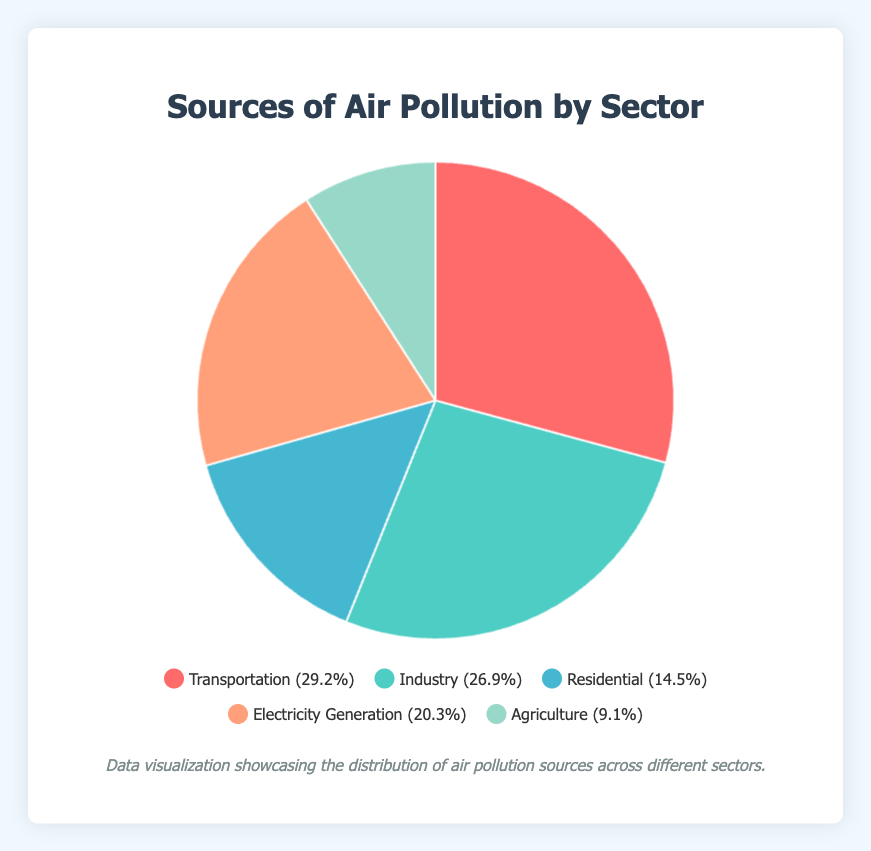How much more does the Transportation sector contribute to air pollution compared to the Residential sector? To find this, subtract the percentage of the Residential sector from the percentage of the Transportation sector: 29.2% - 14.5% = 14.7%
Answer: 14.7% What is the combined percentage of air pollution from the Industry and Electricity Generation sectors? Add together the percentages of the Industry and Electricity Generation sectors: 26.9% + 20.3% = 47.2%
Answer: 47.2% Out of the subcategories within the Transportation sector, which contributes the most to air pollution? The subcategory with the highest percentage under the Transportation sector is Passenger Vehicles at 15.0%
Answer: Passenger Vehicles How does the air pollution contribution from Manufacturing compare to the total contribution of the Residential sector? Compare the percentages: Manufacturing contributes 12.5% while the Residential sector contributes 14.5%. Manufacturing is 2.0% less.
Answer: 2.0% less Which sector has the smallest percentage of air pollution contribution, and what is that value? The Agriculture sector has the smallest percentage contribution at 9.1%
Answer: Agriculture, 9.1% How much do Livestock Emissions contribute to air pollution within the Agriculture sector? The percentage for Livestock Emissions within the Agriculture sector is 5.0%
Answer: 5.0% What is the difference in air pollution contribution between the highest and lowest contributing subcategories within the Electricity Generation sector? The highest-contributing subcategory is Coal-Fired Power Plants at 10.5%, and the lowest is Renewable Energy at 2.0%. The difference is 10.5% - 2.0% = 8.5%
Answer: 8.5% Calculate the percentage of air pollution contributed by non-transportation sectors combined. Sum the percentages of Industry, Residential, Electricity Generation, and Agriculture sectors: 26.9% + 14.5% + 20.3% + 9.1% = 70.8%
Answer: 70.8% How does the percentage of air pollution from Natural Gas Power Plants compare to that of Cooking Emissions? Natural Gas Power Plants contribute 5.0%, while Cooking Emissions contribute 4.0%. Natural Gas is 1.0% higher
Answer: Natural Gas is 1.0% higher 